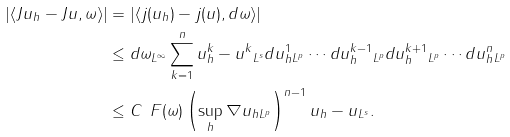<formula> <loc_0><loc_0><loc_500><loc_500>| \langle J u _ { h } - J u , \omega \rangle | & = | \langle j ( u _ { h } ) - j ( u ) , d \omega \rangle | \\ & \leq \| d \omega \| _ { L ^ { \infty } } \sum _ { k = 1 } ^ { n } \| u ^ { k } _ { h } - u ^ { k } \| _ { L ^ { s } } \| d u ^ { 1 } _ { h } \| _ { L ^ { p } } \cdots \| d u ^ { k - 1 } _ { h } \| _ { L ^ { p } } \| d u ^ { k + 1 } _ { h } \| _ { L ^ { p } } \cdots \| d u ^ { n } _ { h } \| _ { L ^ { p } } \\ & \leq C \, \ F ( \omega ) \left ( \sup _ { h } \| \nabla u _ { h } \| _ { L ^ { p } } \right ) ^ { n - 1 } \| u _ { h } - u \| _ { L ^ { s } } .</formula> 